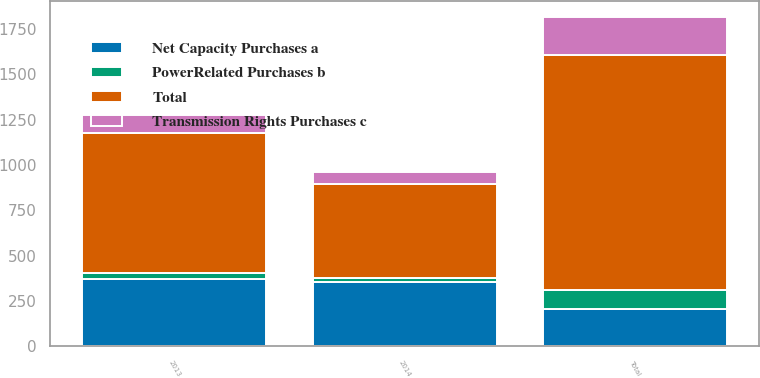Convert chart. <chart><loc_0><loc_0><loc_500><loc_500><stacked_bar_chart><ecel><fcel>2013<fcel>2014<fcel>Total<nl><fcel>Net Capacity Purchases a<fcel>374<fcel>353<fcel>208<nl><fcel>Transmission Rights Purchases c<fcel>95<fcel>69<fcel>208<nl><fcel>PowerRelated Purchases b<fcel>28<fcel>26<fcel>105<nl><fcel>Total<fcel>777<fcel>516<fcel>1293<nl></chart> 